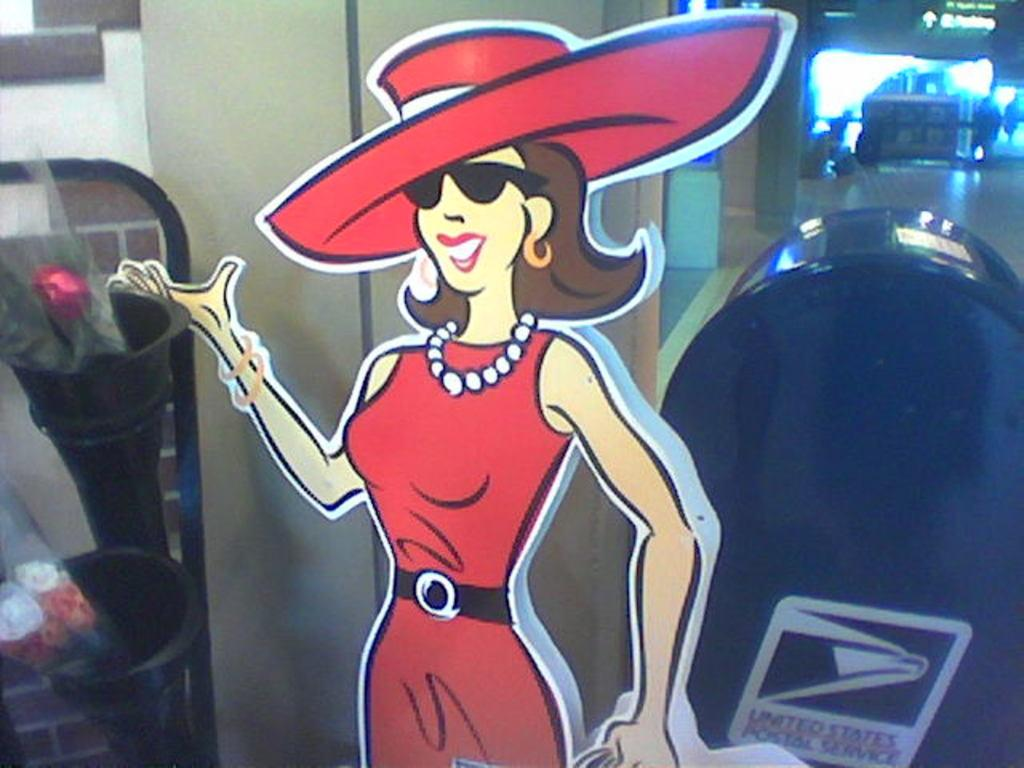<image>
Give a short and clear explanation of the subsequent image. a cut out of a woman dressed in all red in front of a mail box 